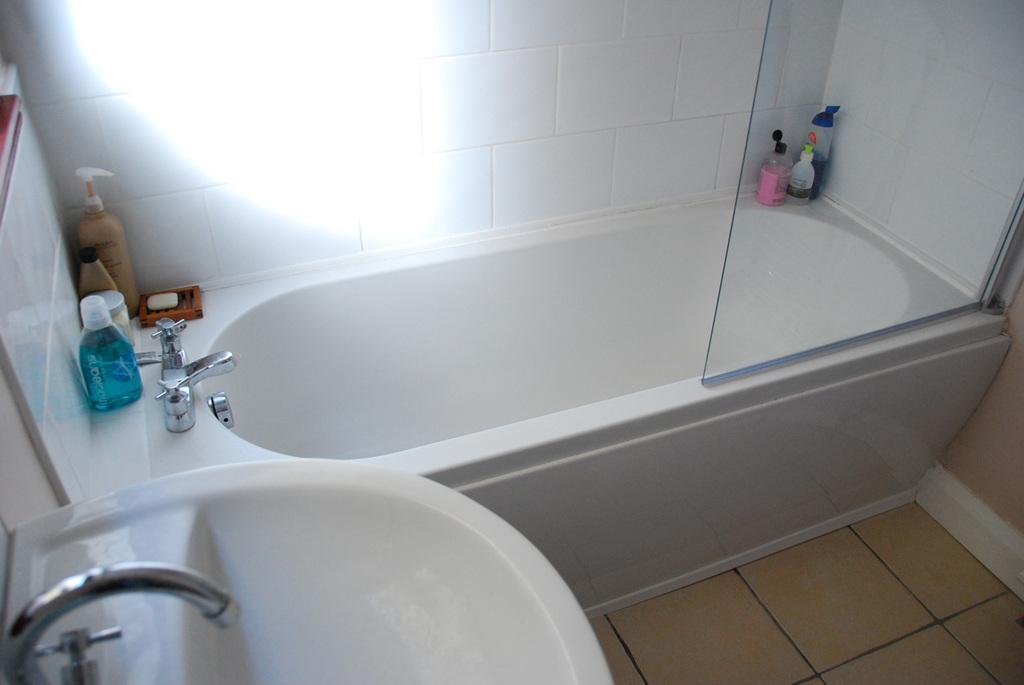Please provide a concise description of this image. This picture is clicked in the washroom. In the left bottom, we see the wash basin. Beside that, we see the cream bottles, lotion bottles and a soap. We see the bathtub. We even see the glass and some lotion bottles. In the background, we see a wall which is made up of white color tiles. 